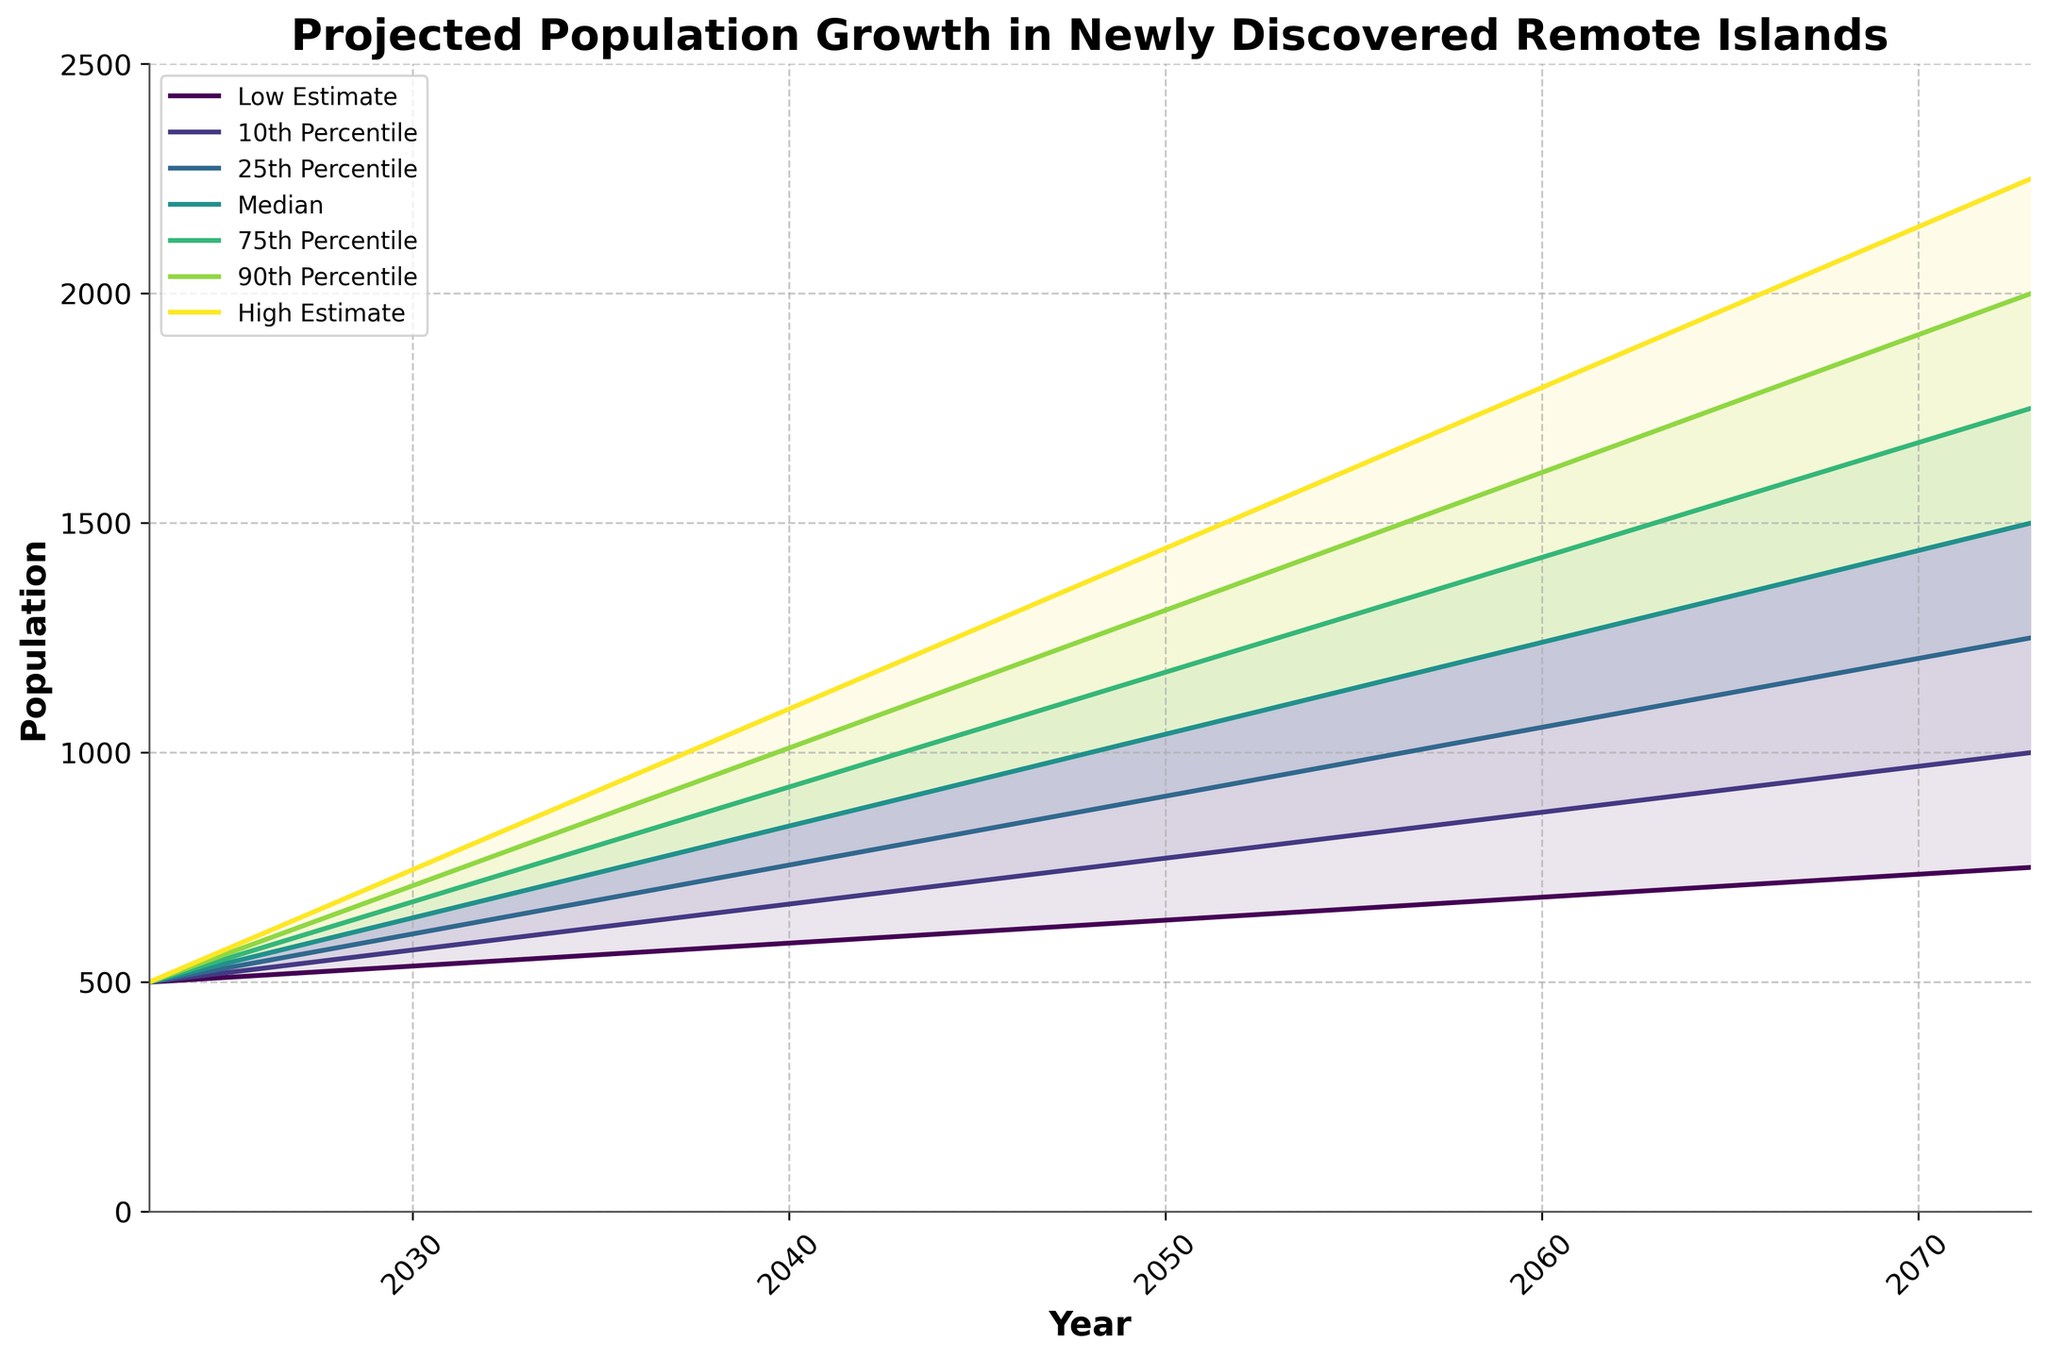What's the title of the chart? The title of the chart is typically found at the top of the figure and is bold and large in size. Here, it is written, 'Projected Population Growth in Newly Discovered Remote Islands'.
Answer: Projected Population Growth in Newly Discovered Remote Islands What does the x-axis represent? The x-axis represents the time frame over which the population growth is projected. It is labeled 'Year' and ranges from 2023 to 2073.
Answer: Year What is the median population estimate for the year 2053? To find the median population estimate for 2053, locate the '2053' mark on the x-axis and follow it to the 'Median' line in the chart. The value given on the y-axis at this point is 1100.
Answer: 1100 How does the median population estimate change from 2023 to 2073? To determine the change in median population estimate from 2023 to 2073, locate the 'Median' line values at both years. In 2023, the median is 500, and in 2073, it's 1500. Subtract the 2023 value from the 2073 value: 1500 - 500 = 1000.
Answer: 1000 What is the population range between the 10th and 90th percentiles in the year 2043? To find the population range between these percentiles in 2043, locate the values for the 10th and 90th percentiles. The 10th percentile is 700 and the 90th percentile is 1100. Subtract the lower value from the higher value: 1100 - 700 = 400.
Answer: 400 At which year does the high estimate first reach 2250? To determine the year when the high estimate first reaches 2250, follow the high estimate line across different years until you find the value 2250. The chart shows this value at the year 2073.
Answer: 2073 What is the difference between the 75th percentile and the Low Estimate in the year 2063? Find the values for the 75th percentile and the Low Estimate in 2063. The 75th percentile is 1500 and the Low Estimate is 700. Subtract the Low Estimate from the 75th percentile: 1500 - 700 = 800.
Answer: 800 By how many does the 25th percentile increase from 2033 to 2053? To calculate this increase, locate the 25th percentile values for these two years. The value in 2033 is 650, and in 2053 it is 950. Subtract the 2033 value from the 2053 value: 950 - 650 = 300.
Answer: 300 Is the population growth more spread out (i.e., greater range) in 2033 or 2063? Calculate the range for both years by subtracting the Low Estimate from the High Estimate. In 2033, the range is 850 - 550 = 300. In 2063, the range is 1900 - 700 = 1200. Compare the two ranges: 1200 is greater than 300.
Answer: 2063 